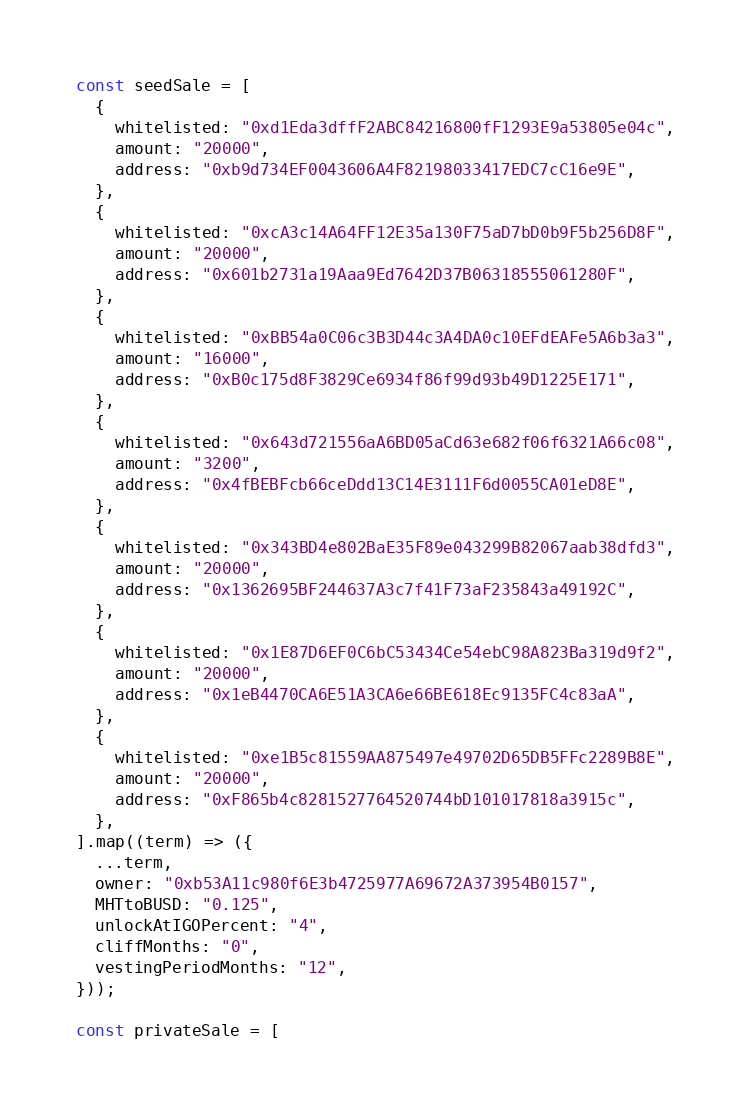Convert code to text. <code><loc_0><loc_0><loc_500><loc_500><_TypeScript_>const seedSale = [
  {
    whitelisted: "0xd1Eda3dffF2ABC84216800fF1293E9a53805e04c",
    amount: "20000",
    address: "0xb9d734EF0043606A4F82198033417EDC7cC16e9E",
  },
  {
    whitelisted: "0xcA3c14A64FF12E35a130F75aD7bD0b9F5b256D8F",
    amount: "20000",
    address: "0x601b2731a19Aaa9Ed7642D37B06318555061280F",
  },
  {
    whitelisted: "0xBB54a0C06c3B3D44c3A4DA0c10EFdEAFe5A6b3a3",
    amount: "16000",
    address: "0xB0c175d8F3829Ce6934f86f99d93b49D1225E171",
  },
  {
    whitelisted: "0x643d721556aA6BD05aCd63e682f06f6321A66c08",
    amount: "3200",
    address: "0x4fBEBFcb66ceDdd13C14E3111F6d0055CA01eD8E",
  },
  {
    whitelisted: "0x343BD4e802BaE35F89e043299B82067aab38dfd3",
    amount: "20000",
    address: "0x1362695BF244637A3c7f41F73aF235843a49192C",
  },
  {
    whitelisted: "0x1E87D6EF0C6bC53434Ce54ebC98A823Ba319d9f2",
    amount: "20000",
    address: "0x1eB4470CA6E51A3CA6e66BE618Ec9135FC4c83aA",
  },
  {
    whitelisted: "0xe1B5c81559AA875497e49702D65DB5FFc2289B8E",
    amount: "20000",
    address: "0xF865b4c8281527764520744bD101017818a3915c",
  },
].map((term) => ({
  ...term,
  owner: "0xb53A11c980f6E3b4725977A69672A373954B0157",
  MHTtoBUSD: "0.125",
  unlockAtIGOPercent: "4",
  cliffMonths: "0",
  vestingPeriodMonths: "12",
}));

const privateSale = [</code> 